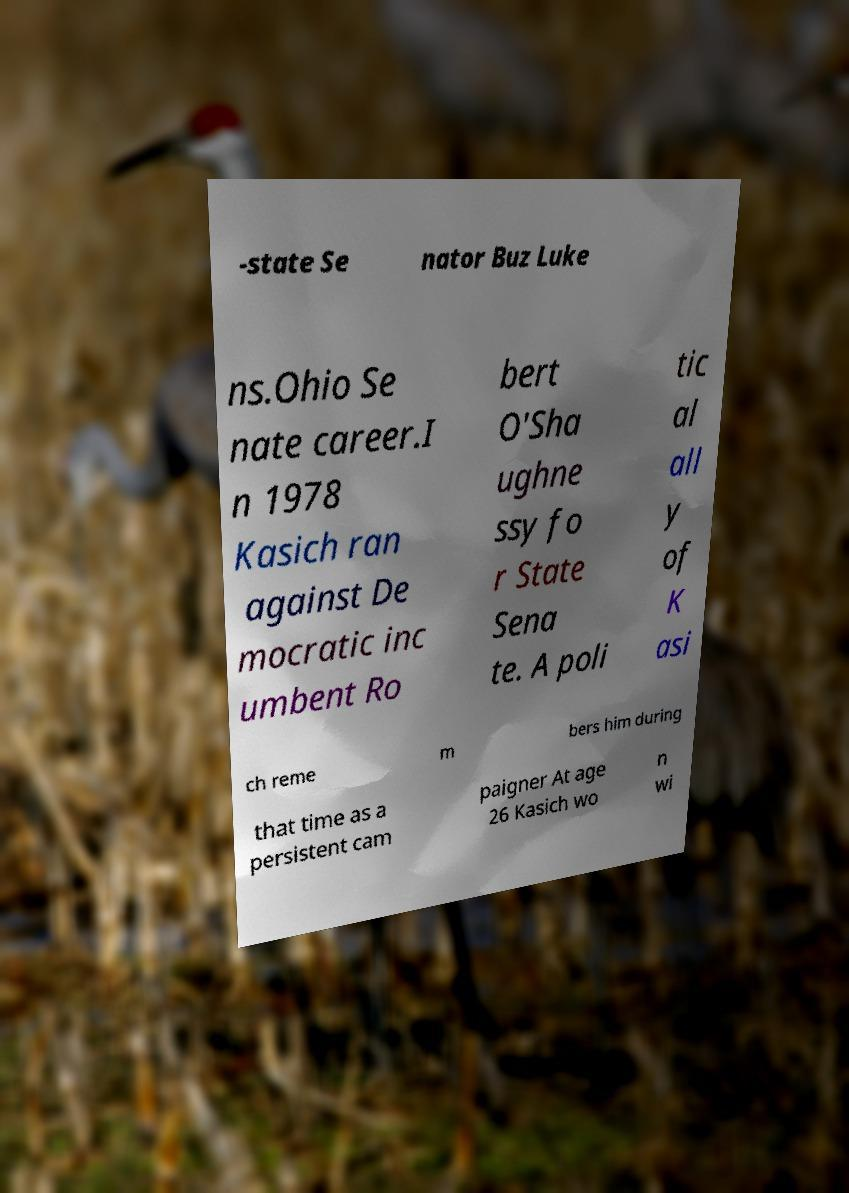I need the written content from this picture converted into text. Can you do that? -state Se nator Buz Luke ns.Ohio Se nate career.I n 1978 Kasich ran against De mocratic inc umbent Ro bert O'Sha ughne ssy fo r State Sena te. A poli tic al all y of K asi ch reme m bers him during that time as a persistent cam paigner At age 26 Kasich wo n wi 